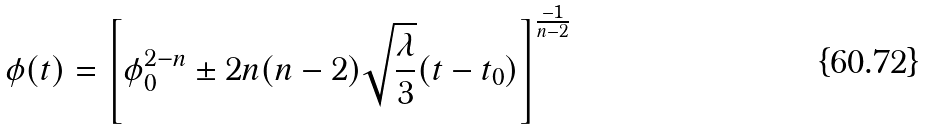<formula> <loc_0><loc_0><loc_500><loc_500>\phi ( t ) = \left [ \phi _ { 0 } ^ { 2 - n } \pm 2 n ( n - 2 ) \sqrt { \frac { \lambda } { 3 } } ( t - t _ { 0 } ) \right ] ^ { \frac { - 1 } { n - 2 } }</formula> 